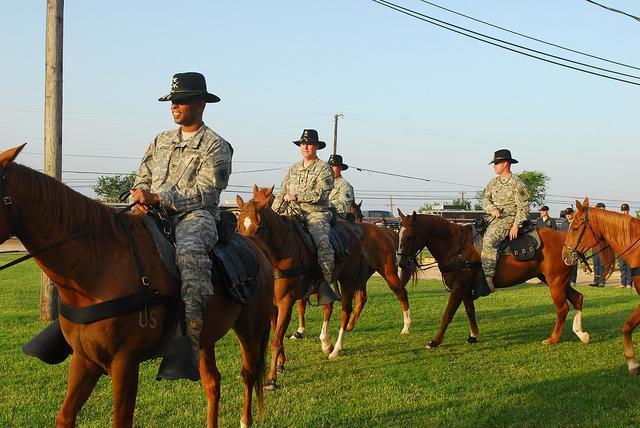How many horse are there?
Give a very brief answer. 5. How many horses are there?
Give a very brief answer. 5. How many people are there?
Give a very brief answer. 3. 